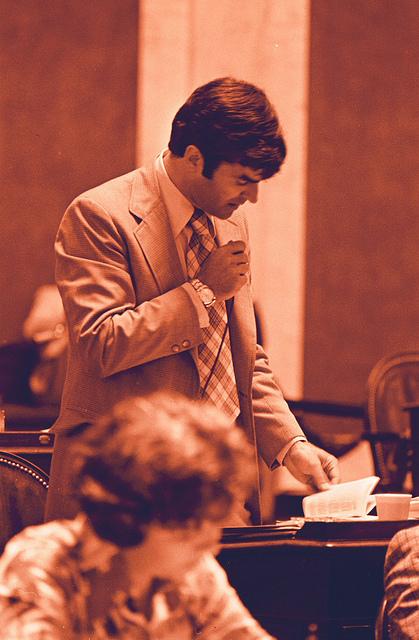How many cups are there?
Answer briefly. 1. What pattern is the man's tie?
Quick response, please. Plaid. Is this a color photo?
Answer briefly. No. 